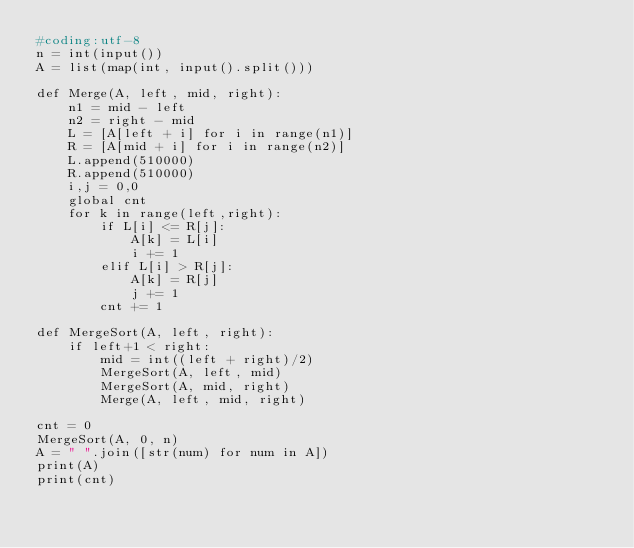<code> <loc_0><loc_0><loc_500><loc_500><_Python_>#coding:utf-8
n = int(input())
A = list(map(int, input().split()))

def Merge(A, left, mid, right):
    n1 = mid - left
    n2 = right - mid
    L = [A[left + i] for i in range(n1)]
    R = [A[mid + i] for i in range(n2)]
    L.append(510000)
    R.append(510000)
    i,j = 0,0
    global cnt
    for k in range(left,right):
        if L[i] <= R[j]:
            A[k] = L[i]
            i += 1
        elif L[i] > R[j]:
            A[k] = R[j]
            j += 1
        cnt += 1

def MergeSort(A, left, right):
    if left+1 < right:
        mid = int((left + right)/2)
        MergeSort(A, left, mid)
        MergeSort(A, mid, right)
        Merge(A, left, mid, right)
    
cnt = 0
MergeSort(A, 0, n)
A = " ".join([str(num) for num in A])
print(A)
print(cnt)
</code> 